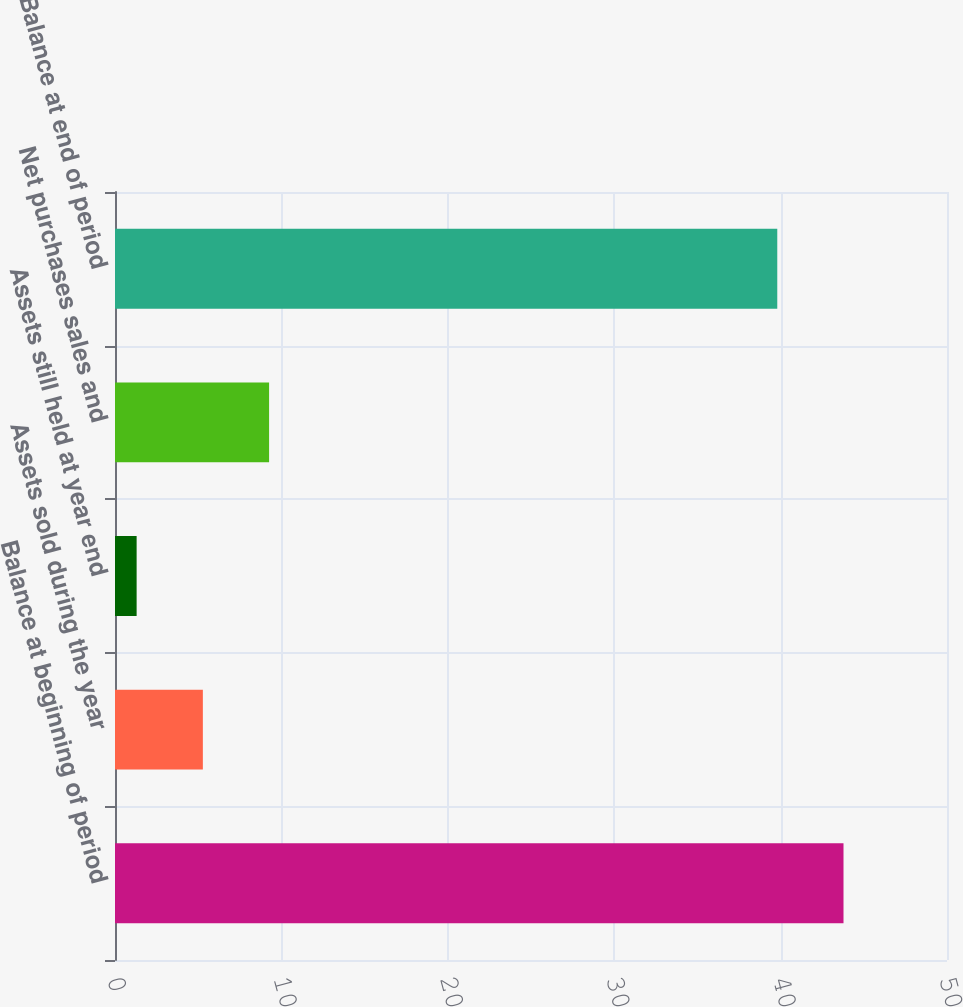<chart> <loc_0><loc_0><loc_500><loc_500><bar_chart><fcel>Balance at beginning of period<fcel>Assets sold during the year<fcel>Assets still held at year end<fcel>Net purchases sales and<fcel>Balance at end of period<nl><fcel>43.78<fcel>5.28<fcel>1.3<fcel>9.26<fcel>39.8<nl></chart> 